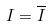Convert formula to latex. <formula><loc_0><loc_0><loc_500><loc_500>I = \overline { I }</formula> 